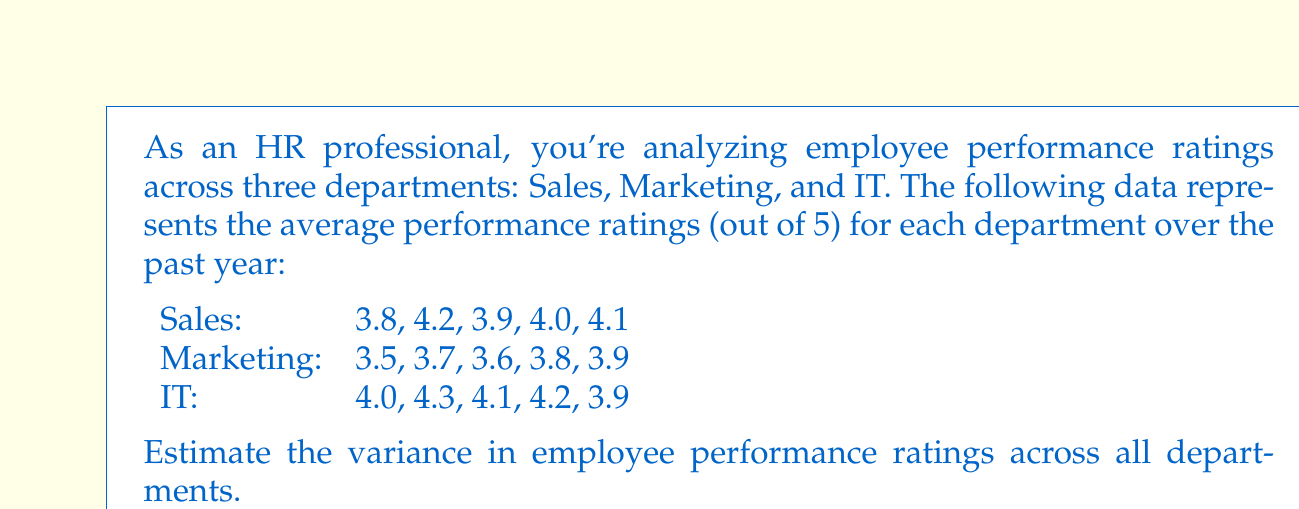Can you answer this question? To estimate the variance in employee performance ratings across all departments, we'll follow these steps:

1. Calculate the overall mean (μ) of all ratings:
   $\mu = \frac{\text{Sum of all ratings}}{\text{Total number of ratings}}$
   $\mu = \frac{(3.8 + 4.2 + 3.9 + 4.0 + 4.1) + (3.5 + 3.7 + 3.6 + 3.8 + 3.9) + (4.0 + 4.3 + 4.1 + 4.2 + 3.9)}{15}$
   $\mu = \frac{59.0}{15} = 3.93333$

2. Calculate the squared differences from the mean for each rating:
   $(3.8 - 3.93333)^2 = 0.01778$
   $(4.2 - 3.93333)^2 = 0.07111$
   ...
   $(3.9 - 3.93333)^2 = 0.00111$

3. Sum up all the squared differences:
   $\text{Sum of squared differences} = 0.01778 + 0.07111 + ... + 0.00111 = 0.83555$

4. Calculate the variance using the formula:
   $\text{Variance} = \frac{\text{Sum of squared differences}}{\text{Number of ratings} - 1}$
   $\text{Variance} = \frac{0.83555}{15 - 1} = \frac{0.83555}{14} = 0.05968$

Therefore, the estimated variance in employee performance ratings across all departments is approximately 0.05968.
Answer: 0.05968 